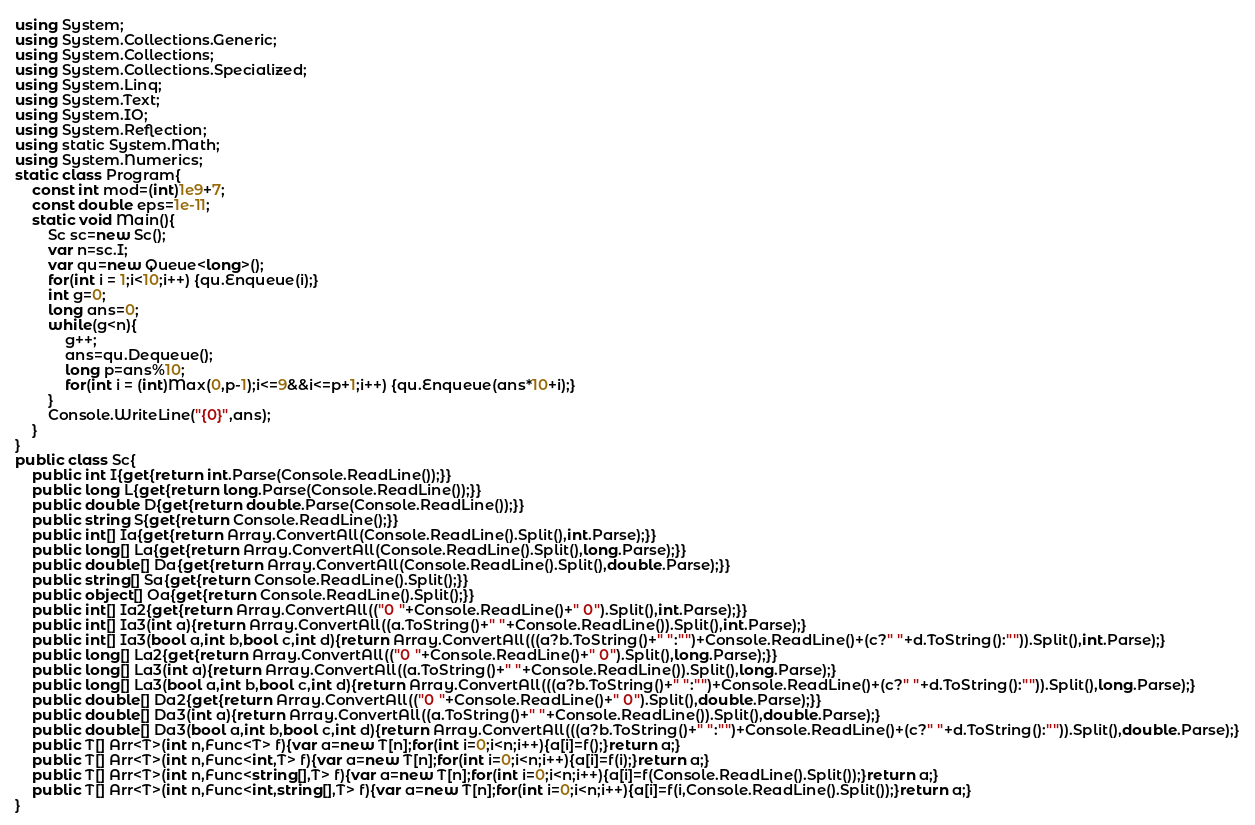Convert code to text. <code><loc_0><loc_0><loc_500><loc_500><_C#_>using System;
using System.Collections.Generic;
using System.Collections;
using System.Collections.Specialized;
using System.Linq;
using System.Text;
using System.IO;
using System.Reflection;
using static System.Math;
using System.Numerics;
static class Program{
	const int mod=(int)1e9+7;
	const double eps=1e-11;
	static void Main(){
		Sc sc=new Sc();
		var n=sc.I;
		var qu=new Queue<long>();
		for(int i = 1;i<10;i++) {qu.Enqueue(i);}
		int g=0;
		long ans=0;
		while(g<n){
			g++;
			ans=qu.Dequeue();
			long p=ans%10;
			for(int i = (int)Max(0,p-1);i<=9&&i<=p+1;i++) {qu.Enqueue(ans*10+i);}
		}
		Console.WriteLine("{0}",ans);
	}
}
public class Sc{
	public int I{get{return int.Parse(Console.ReadLine());}}
	public long L{get{return long.Parse(Console.ReadLine());}}
	public double D{get{return double.Parse(Console.ReadLine());}}
	public string S{get{return Console.ReadLine();}}
	public int[] Ia{get{return Array.ConvertAll(Console.ReadLine().Split(),int.Parse);}}
	public long[] La{get{return Array.ConvertAll(Console.ReadLine().Split(),long.Parse);}}
	public double[] Da{get{return Array.ConvertAll(Console.ReadLine().Split(),double.Parse);}}
	public string[] Sa{get{return Console.ReadLine().Split();}}
	public object[] Oa{get{return Console.ReadLine().Split();}}
	public int[] Ia2{get{return Array.ConvertAll(("0 "+Console.ReadLine()+" 0").Split(),int.Parse);}}
	public int[] Ia3(int a){return Array.ConvertAll((a.ToString()+" "+Console.ReadLine()).Split(),int.Parse);}
	public int[] Ia3(bool a,int b,bool c,int d){return Array.ConvertAll(((a?b.ToString()+" ":"")+Console.ReadLine()+(c?" "+d.ToString():"")).Split(),int.Parse);}
	public long[] La2{get{return Array.ConvertAll(("0 "+Console.ReadLine()+" 0").Split(),long.Parse);}}
	public long[] La3(int a){return Array.ConvertAll((a.ToString()+" "+Console.ReadLine()).Split(),long.Parse);}
	public long[] La3(bool a,int b,bool c,int d){return Array.ConvertAll(((a?b.ToString()+" ":"")+Console.ReadLine()+(c?" "+d.ToString():"")).Split(),long.Parse);}
	public double[] Da2{get{return Array.ConvertAll(("0 "+Console.ReadLine()+" 0").Split(),double.Parse);}}
	public double[] Da3(int a){return Array.ConvertAll((a.ToString()+" "+Console.ReadLine()).Split(),double.Parse);}
	public double[] Da3(bool a,int b,bool c,int d){return Array.ConvertAll(((a?b.ToString()+" ":"")+Console.ReadLine()+(c?" "+d.ToString():"")).Split(),double.Parse);}
	public T[] Arr<T>(int n,Func<T> f){var a=new T[n];for(int i=0;i<n;i++){a[i]=f();}return a;}
	public T[] Arr<T>(int n,Func<int,T> f){var a=new T[n];for(int i=0;i<n;i++){a[i]=f(i);}return a;}
	public T[] Arr<T>(int n,Func<string[],T> f){var a=new T[n];for(int i=0;i<n;i++){a[i]=f(Console.ReadLine().Split());}return a;}
	public T[] Arr<T>(int n,Func<int,string[],T> f){var a=new T[n];for(int i=0;i<n;i++){a[i]=f(i,Console.ReadLine().Split());}return a;}
}</code> 